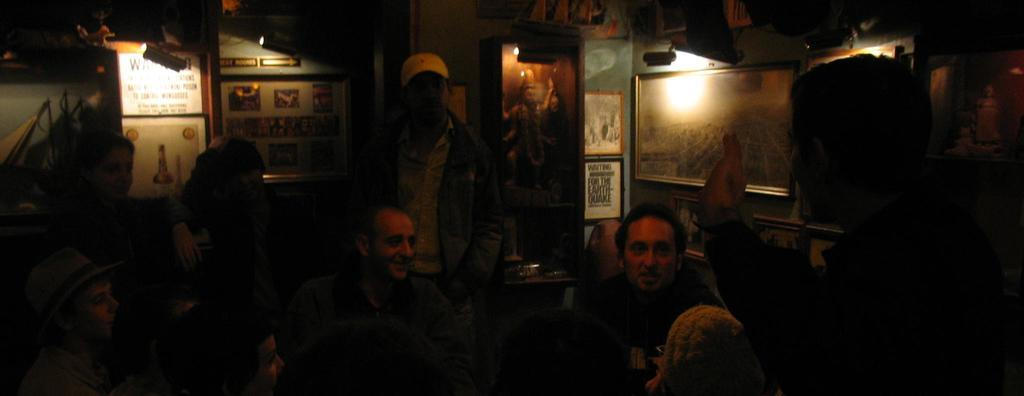What can be seen in the foreground of the picture? There are people, a table, and a chair in the foreground of the picture. What is the purpose of the table in the foreground? The table's purpose is not specified in the image, but it could be used for various activities or as a surface for placing objects. What is visible in the background of the picture? There are lights and frames attached to the wall in the background of the picture. Can you see a spade being used by the people in the foreground of the image? There is no spade present in the image. Are there any giants visible in the image? There are no giants present in the image; the people in the foreground are of normal size. 